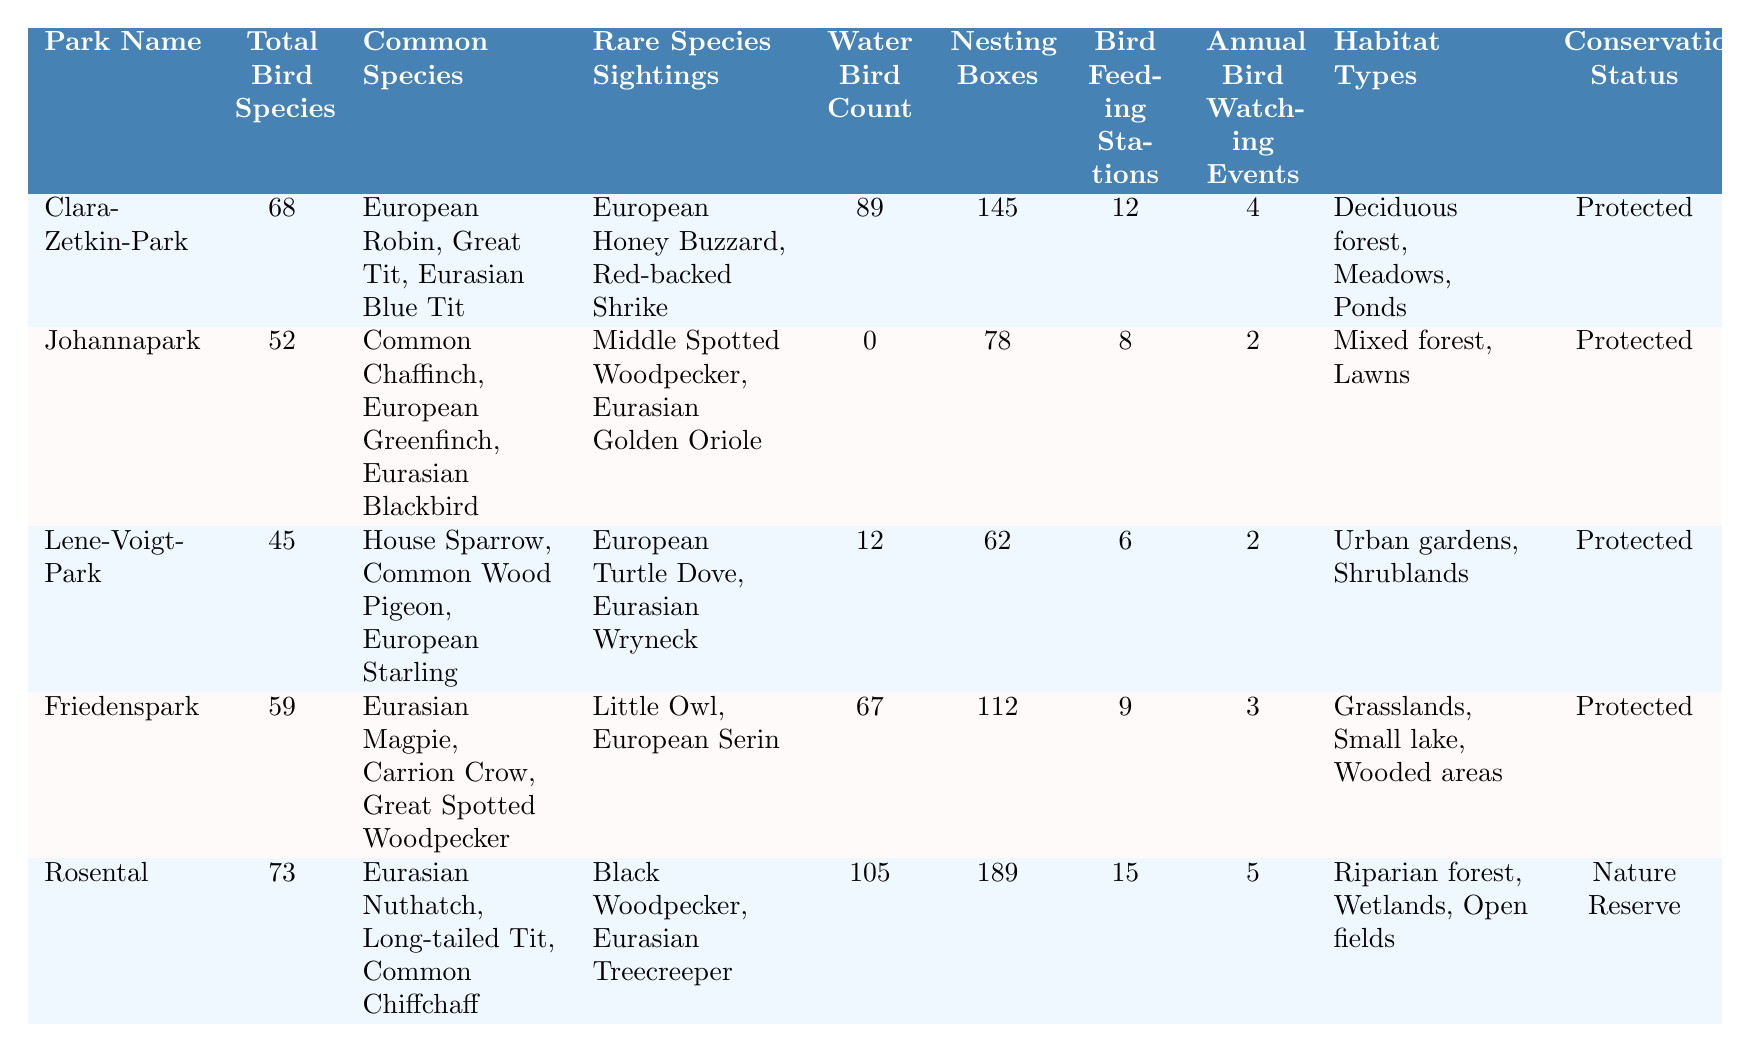What is the total number of bird species in Clara-Zetkin-Park? Looking at the table, the total bird species listed for Clara-Zetkin-Park is 68.
Answer: 68 Which park has the highest number of rare species sightings? The rare species sightings are listed for each park. The highest count is found in Rosental with Black Woodpecker and Eurasian Treecreeper.
Answer: Rosental Does Johannapark have any water birds? Referring to the water bird count, Johannapark has a count of 0 water birds, indicating none are present.
Answer: No What is the average number of nesting boxes across all parks? To find the average, sum the nesting boxes: (145 + 78 + 62 + 112 + 189) = 586, then divide by the number of parks (5), resulting in 586/5 = 117.2.
Answer: 117.2 Which park has the lowest total bird species? By examining the total bird species, Lene-Voigt-Park has the lowest count at 45.
Answer: Lene-Voigt-Park Is Friedenspark a nature reserve? The conservation status of Friedenspark is listed as "Protected," not a nature reserve.
Answer: No How many more common species does Clara-Zetkin-Park have than Lene-Voigt-Park? Clara-Zetkin-Park has 3 common species and Lene-Voigt-Park has 3 as well. Therefore, the difference is 3 - 3 = 0.
Answer: 0 What type of habitat is associated with Rosental? The table indicates that Rosental has a habitat type of riparian forest, wetlands, and open fields.
Answer: Riparian forest, wetlands, open fields Are there more bird feeding stations in Friedenspark than in Lene-Voigt-Park? Friedenspark has 9 bird feeding stations and Lene-Voigt-Park has 6, indicating more in Friedenspark.
Answer: Yes What is the difference in the number of water birds between Rosental and Johannapark? Rosental has 105 water birds and Johannapark has 0. The difference is 105 - 0 = 105.
Answer: 105 What is the total count of annual bird watching events across all parks? Summing the events gives: (4 + 2 + 2 + 3 + 5) = 16 events total.
Answer: 16 